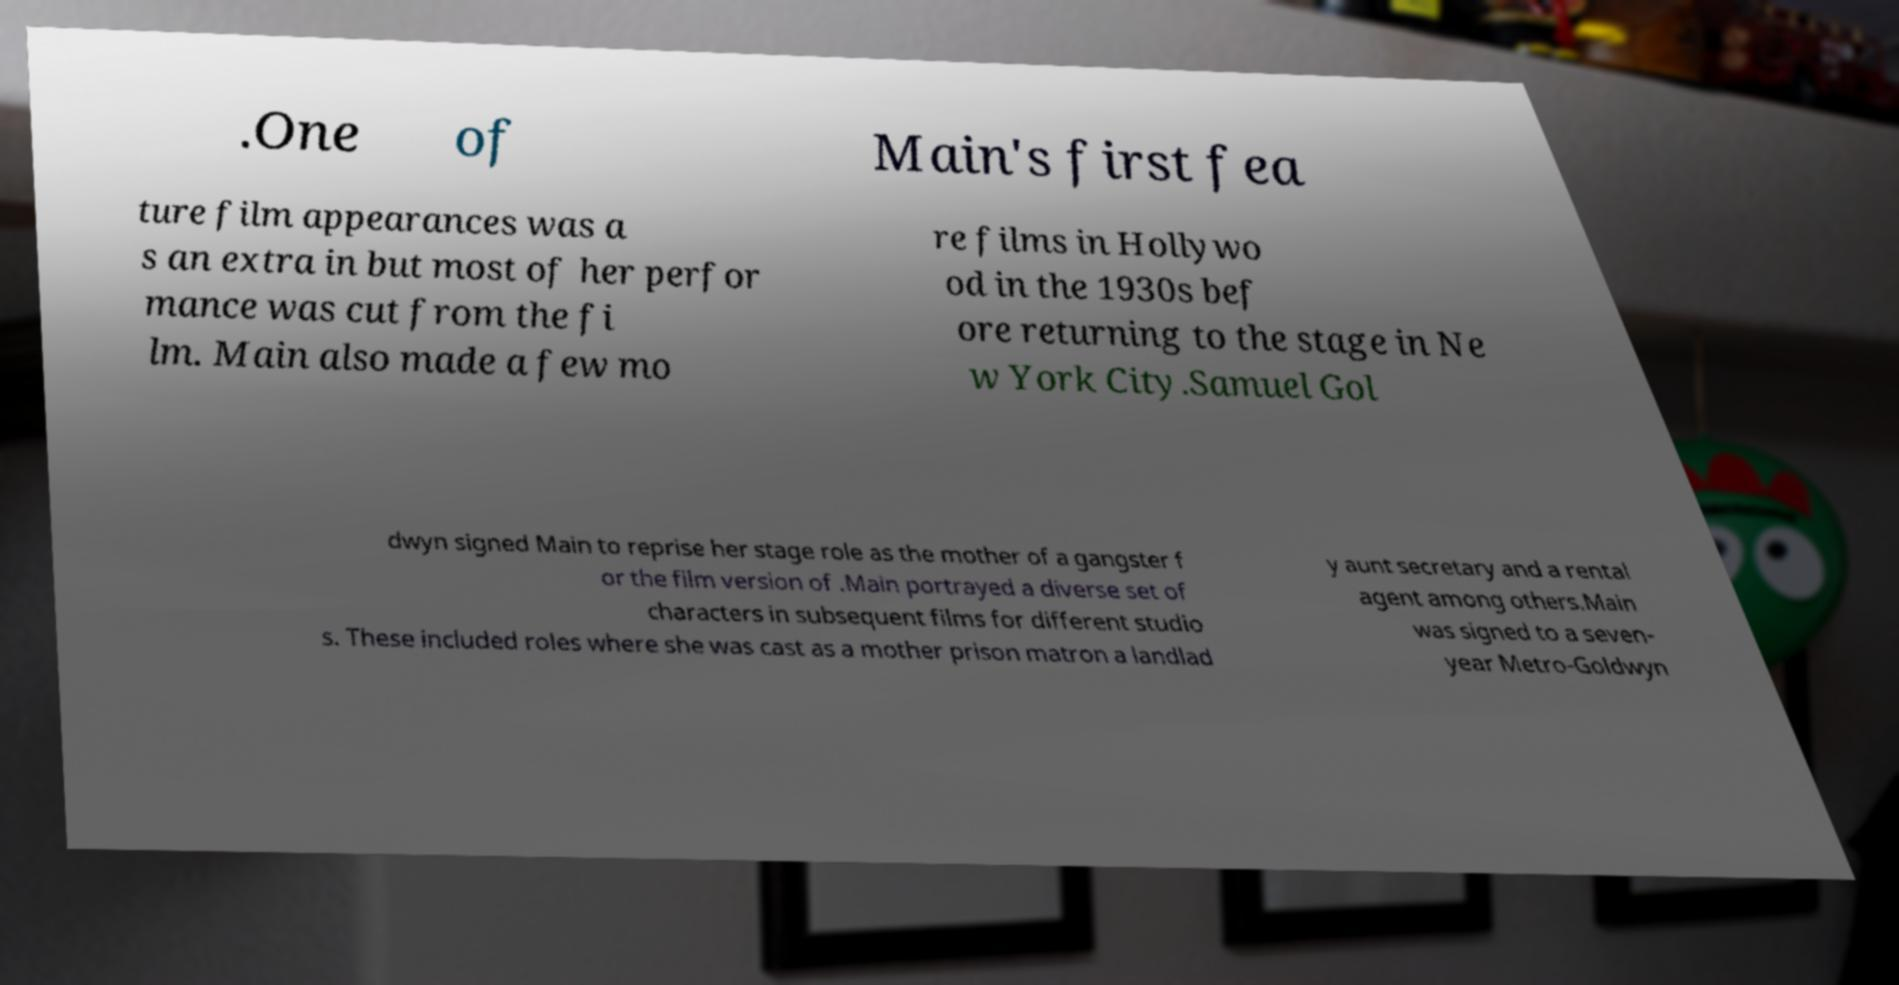Can you accurately transcribe the text from the provided image for me? .One of Main's first fea ture film appearances was a s an extra in but most of her perfor mance was cut from the fi lm. Main also made a few mo re films in Hollywo od in the 1930s bef ore returning to the stage in Ne w York City.Samuel Gol dwyn signed Main to reprise her stage role as the mother of a gangster f or the film version of .Main portrayed a diverse set of characters in subsequent films for different studio s. These included roles where she was cast as a mother prison matron a landlad y aunt secretary and a rental agent among others.Main was signed to a seven- year Metro-Goldwyn 